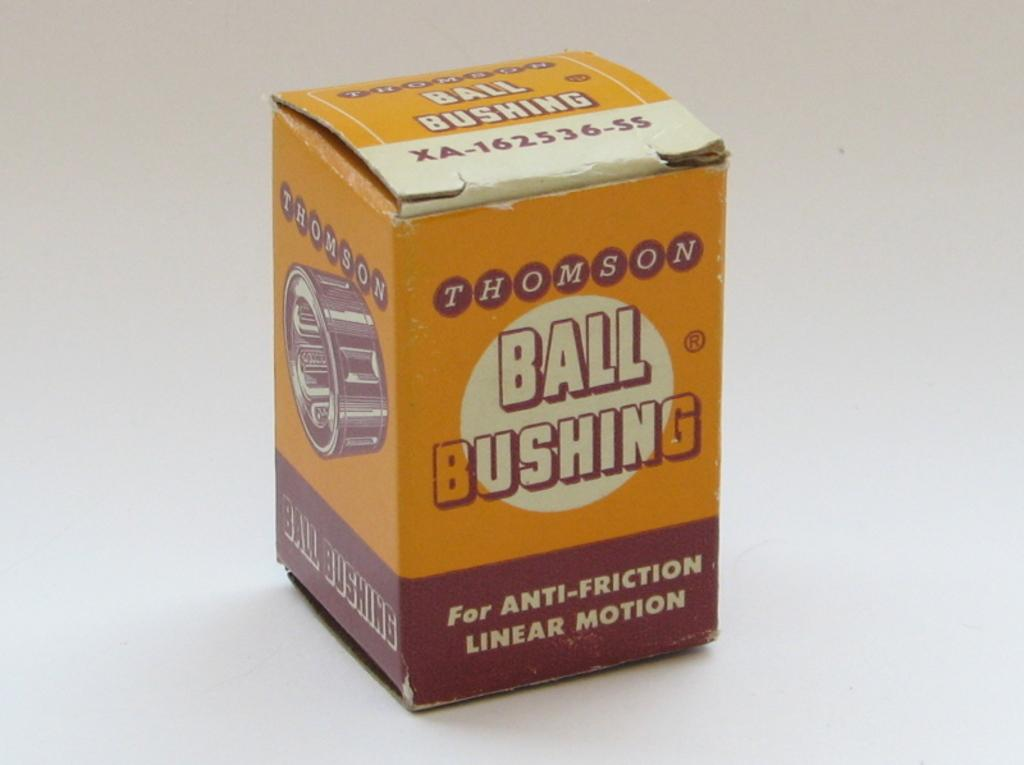What object is present on the white surface in the image? There is a box on the white surface in the image. What is the color of the surface the box is placed on? The surface is white. What can be found on the box itself? There is writing on the box. What type of cream is being served by the queen in the image? There is no queen or cream present in the image; it only features a box on a white surface with writing on it. 